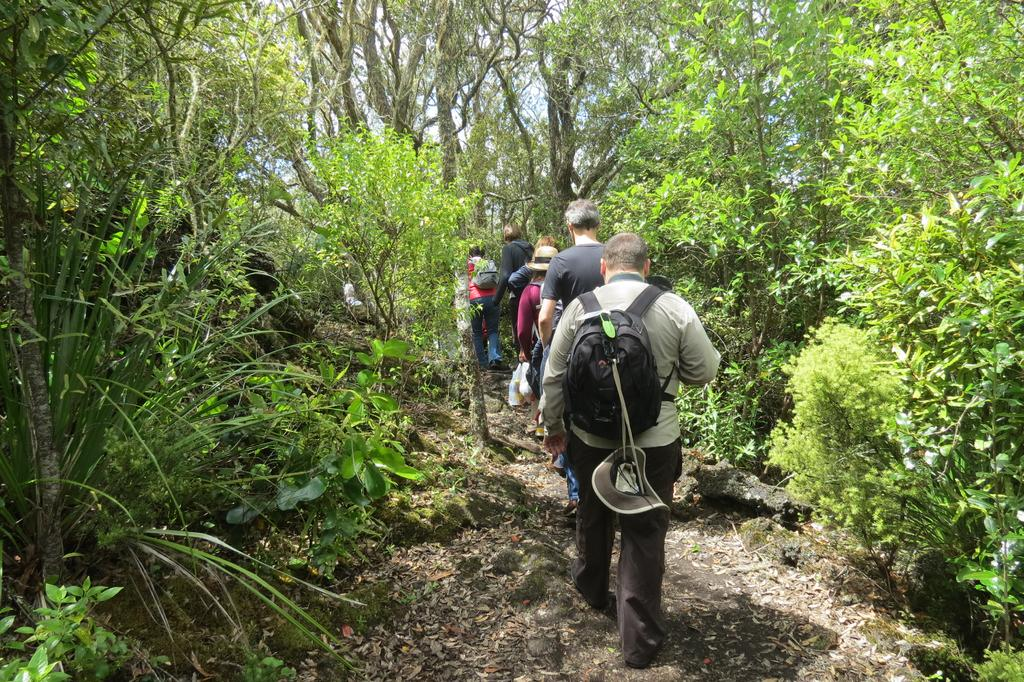What are the people in the image doing? The people in the image are walking. What are the people carrying while walking? The people are carrying bags. What else are the people holding in the image? The people are holding objects. What can be seen on the heads of the people in the image? The people are wearing hats. What type of vegetation is visible in the background of the image? There are trees, plants, and grass visible in the background of the image. What part of the natural environment is visible in the background of the image? The sky is visible in the background of the image. What type of organization is the crow a part of in the image? There is no crow present in the image. 